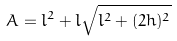Convert formula to latex. <formula><loc_0><loc_0><loc_500><loc_500>A = l ^ { 2 } + l \sqrt { l ^ { 2 } + ( 2 h ) ^ { 2 } }</formula> 